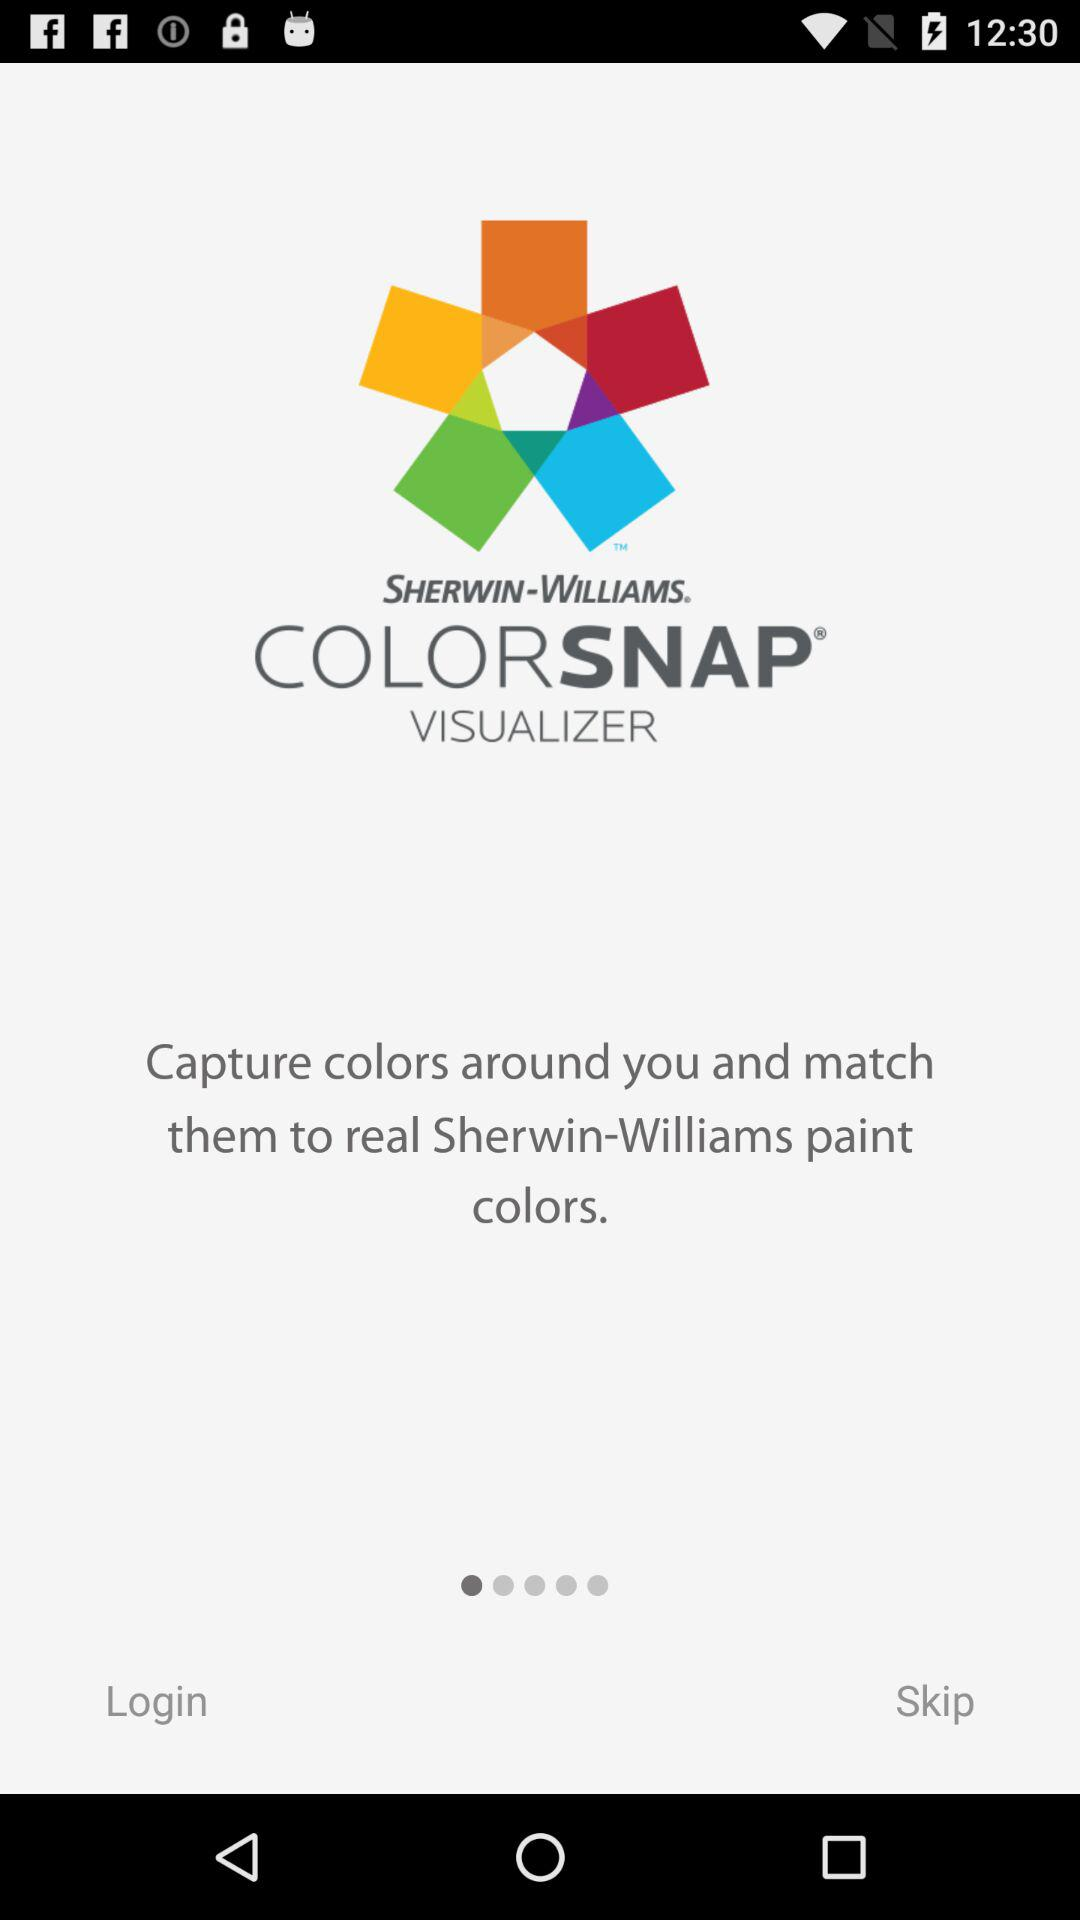What is the application name? The application name is "COLORSNAP VISUALIZER". 